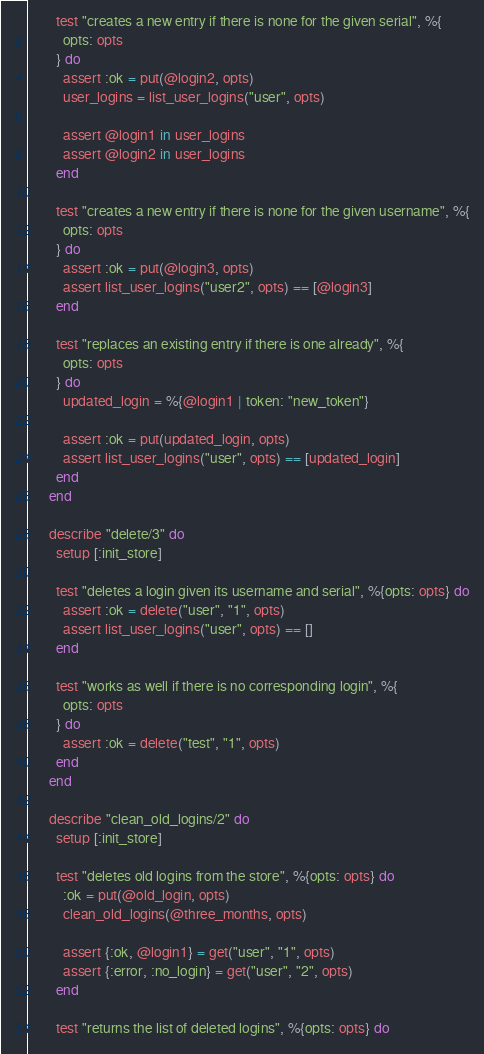<code> <loc_0><loc_0><loc_500><loc_500><_Elixir_>
        test "creates a new entry if there is none for the given serial", %{
          opts: opts
        } do
          assert :ok = put(@login2, opts)
          user_logins = list_user_logins("user", opts)

          assert @login1 in user_logins
          assert @login2 in user_logins
        end

        test "creates a new entry if there is none for the given username", %{
          opts: opts
        } do
          assert :ok = put(@login3, opts)
          assert list_user_logins("user2", opts) == [@login3]
        end

        test "replaces an existing entry if there is one already", %{
          opts: opts
        } do
          updated_login = %{@login1 | token: "new_token"}

          assert :ok = put(updated_login, opts)
          assert list_user_logins("user", opts) == [updated_login]
        end
      end

      describe "delete/3" do
        setup [:init_store]

        test "deletes a login given its username and serial", %{opts: opts} do
          assert :ok = delete("user", "1", opts)
          assert list_user_logins("user", opts) == []
        end

        test "works as well if there is no corresponding login", %{
          opts: opts
        } do
          assert :ok = delete("test", "1", opts)
        end
      end

      describe "clean_old_logins/2" do
        setup [:init_store]

        test "deletes old logins from the store", %{opts: opts} do
          :ok = put(@old_login, opts)
          clean_old_logins(@three_months, opts)

          assert {:ok, @login1} = get("user", "1", opts)
          assert {:error, :no_login} = get("user", "2", opts)
        end

        test "returns the list of deleted logins", %{opts: opts} do</code> 